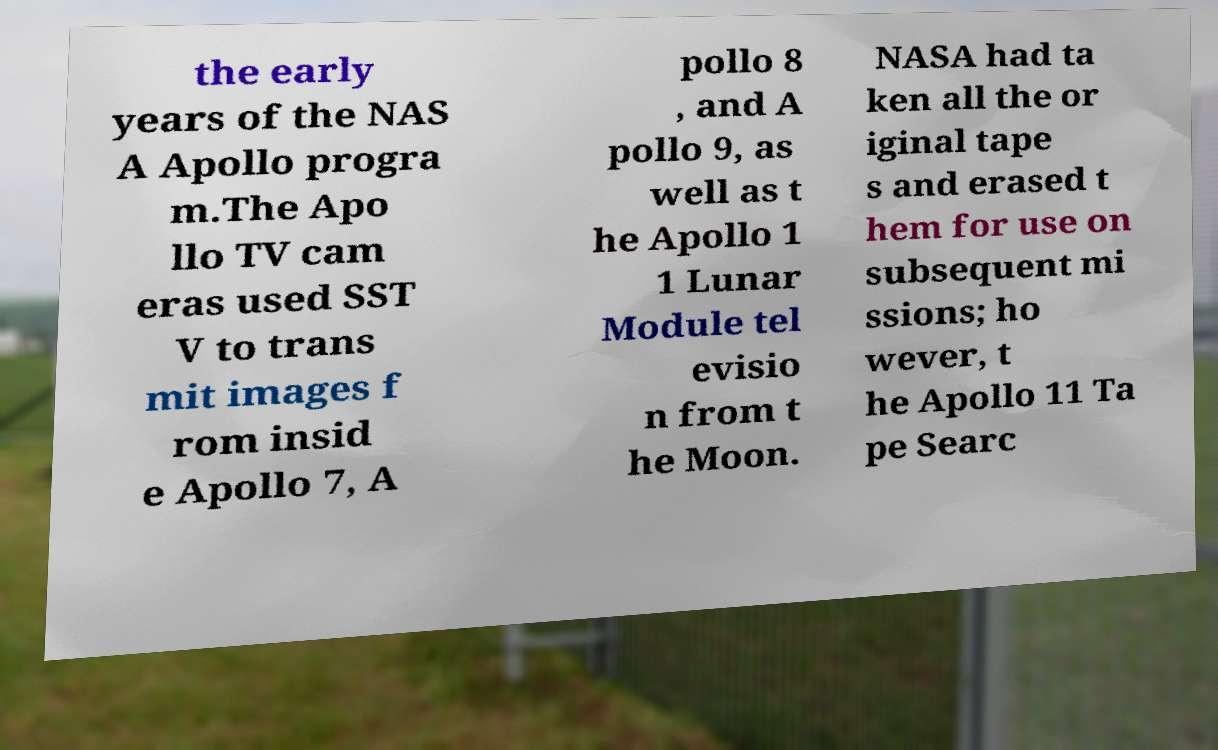What messages or text are displayed in this image? I need them in a readable, typed format. the early years of the NAS A Apollo progra m.The Apo llo TV cam eras used SST V to trans mit images f rom insid e Apollo 7, A pollo 8 , and A pollo 9, as well as t he Apollo 1 1 Lunar Module tel evisio n from t he Moon. NASA had ta ken all the or iginal tape s and erased t hem for use on subsequent mi ssions; ho wever, t he Apollo 11 Ta pe Searc 